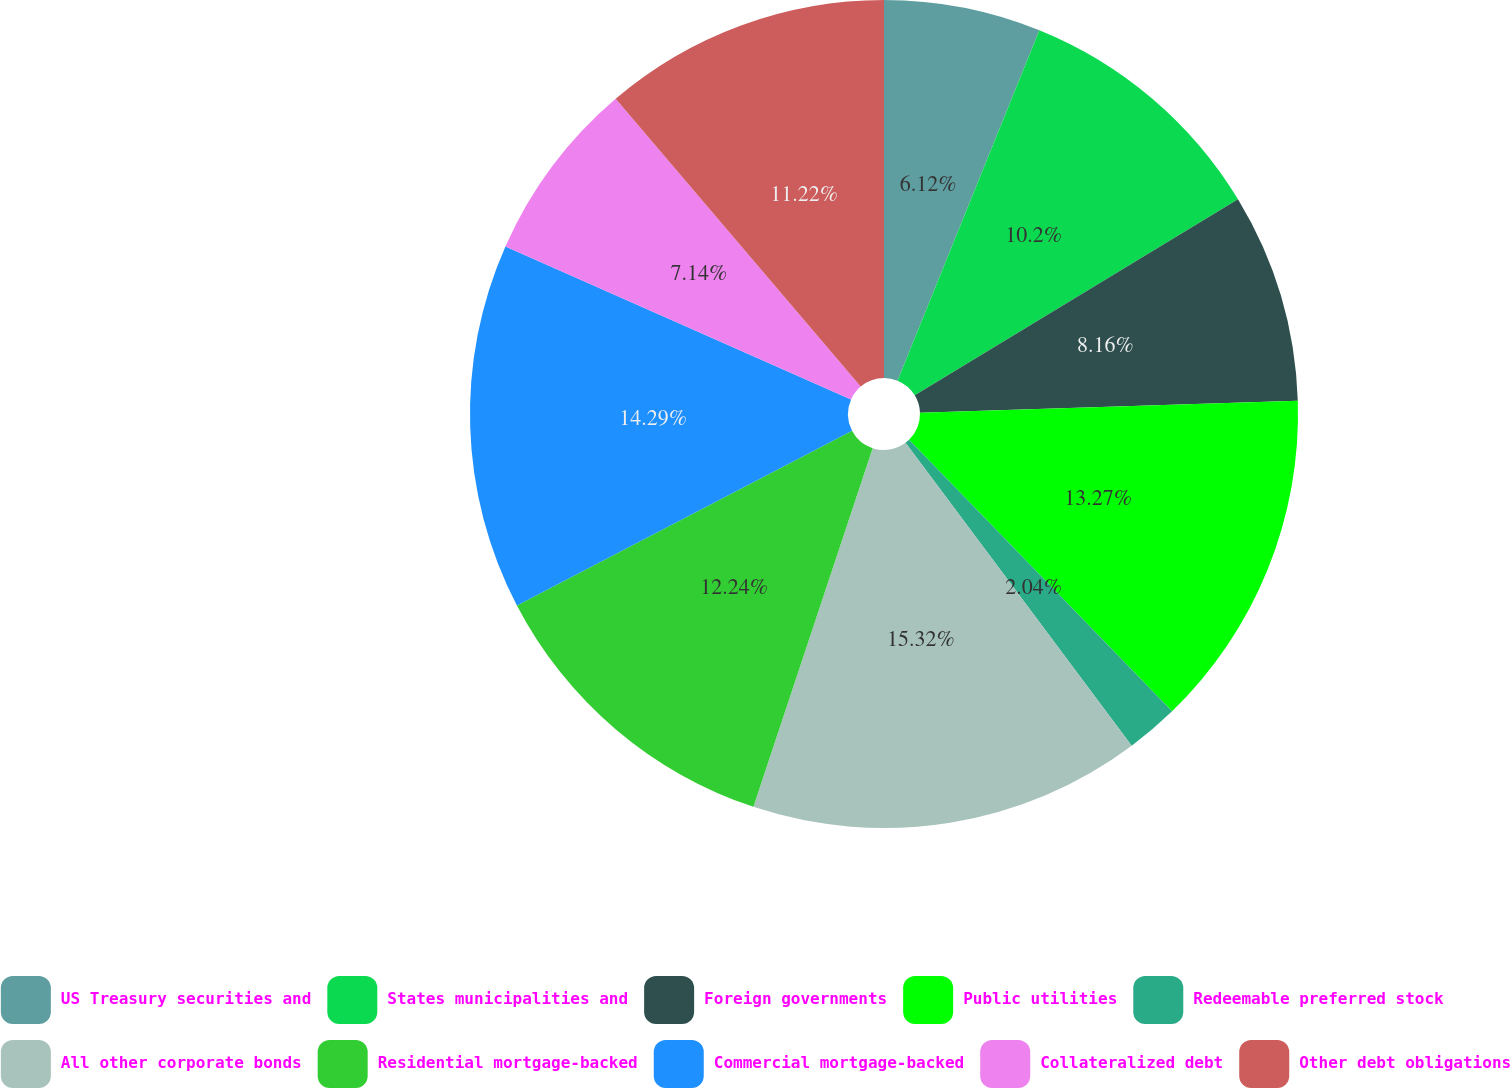Convert chart. <chart><loc_0><loc_0><loc_500><loc_500><pie_chart><fcel>US Treasury securities and<fcel>States municipalities and<fcel>Foreign governments<fcel>Public utilities<fcel>Redeemable preferred stock<fcel>All other corporate bonds<fcel>Residential mortgage-backed<fcel>Commercial mortgage-backed<fcel>Collateralized debt<fcel>Other debt obligations<nl><fcel>6.12%<fcel>10.2%<fcel>8.16%<fcel>13.26%<fcel>2.04%<fcel>15.31%<fcel>12.24%<fcel>14.28%<fcel>7.14%<fcel>11.22%<nl></chart> 